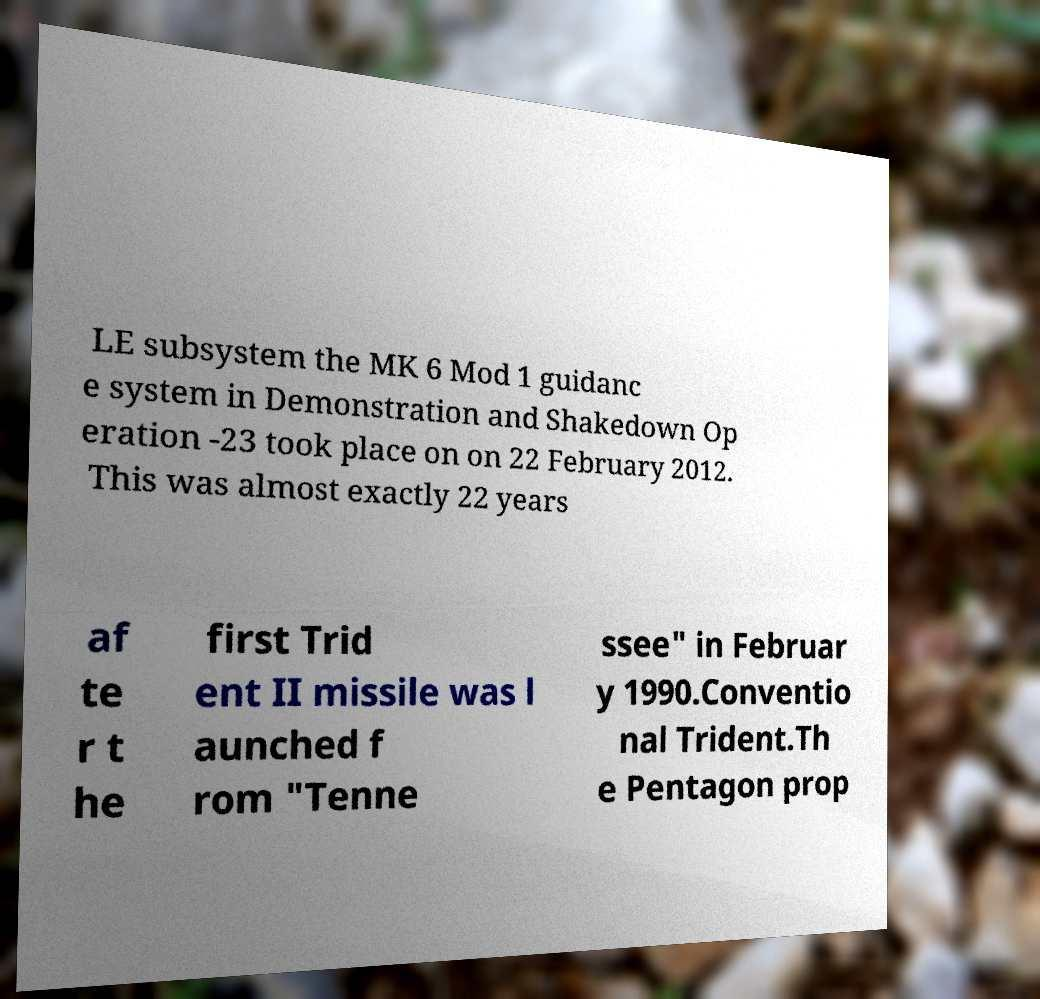Can you read and provide the text displayed in the image?This photo seems to have some interesting text. Can you extract and type it out for me? LE subsystem the MK 6 Mod 1 guidanc e system in Demonstration and Shakedown Op eration -23 took place on on 22 February 2012. This was almost exactly 22 years af te r t he first Trid ent II missile was l aunched f rom "Tenne ssee" in Februar y 1990.Conventio nal Trident.Th e Pentagon prop 